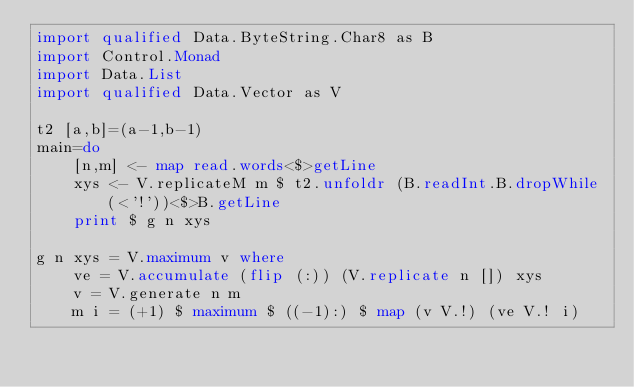Convert code to text. <code><loc_0><loc_0><loc_500><loc_500><_Haskell_>import qualified Data.ByteString.Char8 as B
import Control.Monad
import Data.List
import qualified Data.Vector as V

t2 [a,b]=(a-1,b-1)
main=do
    [n,m] <- map read.words<$>getLine
    xys <- V.replicateM m $ t2.unfoldr (B.readInt.B.dropWhile(<'!'))<$>B.getLine
    print $ g n xys

g n xys = V.maximum v where
    ve = V.accumulate (flip (:)) (V.replicate n []) xys
    v = V.generate n m
    m i = (+1) $ maximum $ ((-1):) $ map (v V.!) (ve V.! i) </code> 